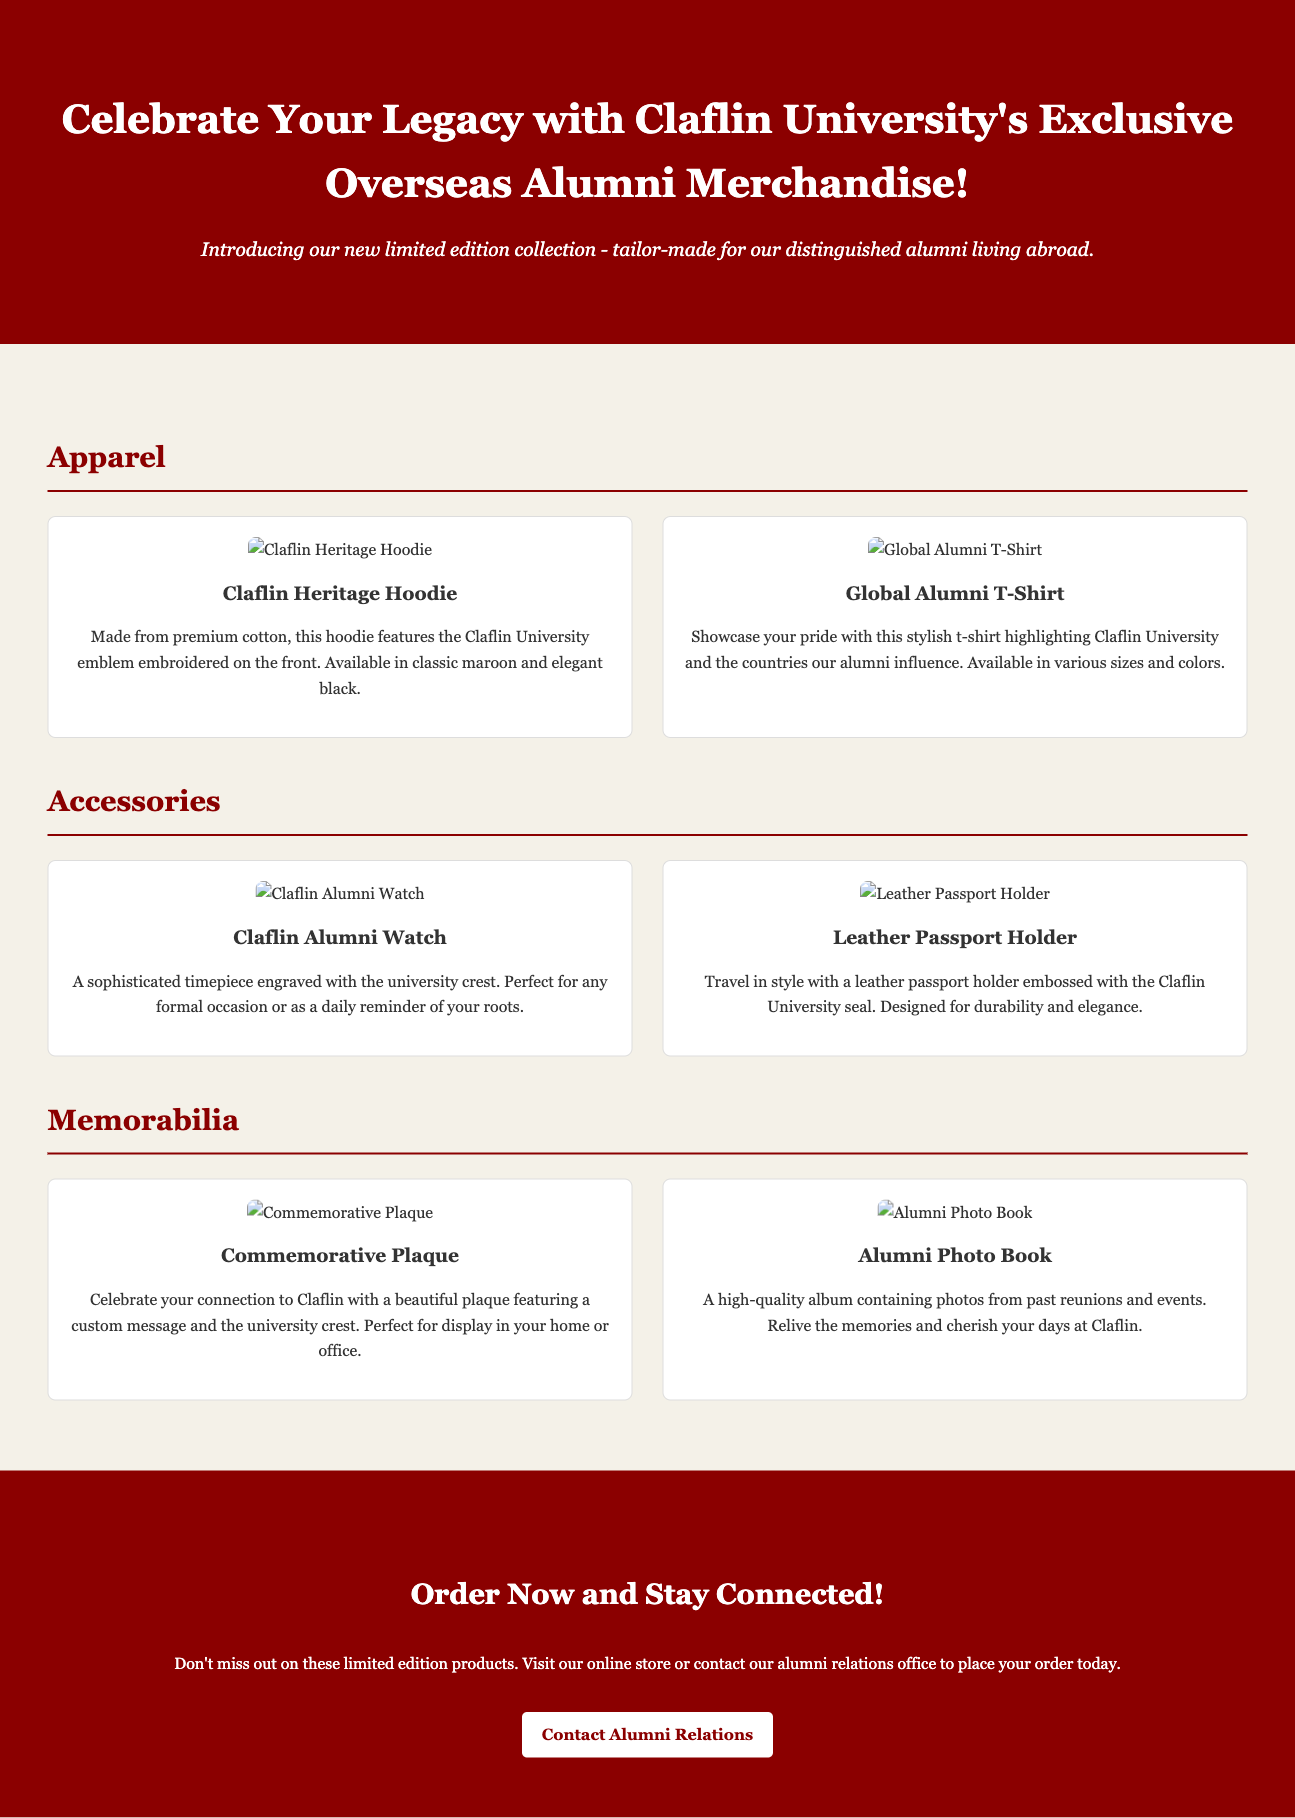What is the name of the hoodie? The hoodie featured in the merchandise is called the Claflin Heritage Hoodie.
Answer: Claflin Heritage Hoodie What color options are available for the Global Alumni T-Shirt? The document mentions that the Global Alumni T-Shirt is available in various sizes and colors, but does not specify the colors.
Answer: Various What item is engraved with the university crest? The Claflin Alumni Watch is the item that is engraved with the university crest.
Answer: Claflin Alumni Watch What type of product is the Leather Passport Holder? The Leather Passport Holder is categorized under accessories in the merchandise lineup.
Answer: Accessory How can alumni place their order? Alumni can place their order by visiting the online store or contacting the alumni relations office.
Answer: Email or online store What is included in the Alumni Photo Book? The Alumni Photo Book contains photos from past reunions and events.
Answer: Photos from past reunions How many product categories are listed in the document? The document lists three product categories: Apparel, Accessories, and Memorabilia.
Answer: Three What does the commemorative plaque feature? The commemorative plaque features a custom message and the university crest.
Answer: Custom message and university crest 